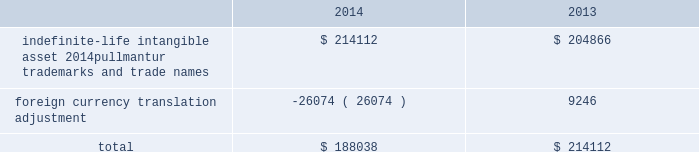Royal caribbean cruises ltd .
79 notes to the consolidated financial statements in 2012 , we determined the implied fair value of good- will for the pullmantur reporting unit was $ 145.5 mil- lion and recognized an impairment charge of $ 319.2 million based on a probability-weighted discounted cash flow model further discussed below .
This impair- ment charge was recognized in earnings during the fourth quarter of 2012 and is reported within impair- ment of pullmantur related assets within our consoli- dated statements of comprehensive income ( loss ) .
During the fourth quarter of 2014 , we performed a qualitative assessment of whether it was more-likely- than-not that our royal caribbean international reporting unit 2019s fair value was less than its carrying amount before applying the two-step goodwill impair- ment test .
The qualitative analysis included assessing the impact of certain factors such as general economic conditions , limitations on accessing capital , changes in forecasted operating results , changes in fuel prices and fluctuations in foreign exchange rates .
Based on our qualitative assessment , we concluded that it was more-likely-than-not that the estimated fair value of the royal caribbean international reporting unit exceeded its carrying value and thus , we did not pro- ceed to the two-step goodwill impairment test .
No indicators of impairment exist primarily because the reporting unit 2019s fair value has consistently exceeded its carrying value by a significant margin , its financial performance has been solid in the face of mixed economic environments and forecasts of operating results generated by the reporting unit appear suffi- cient to support its carrying value .
We also performed our annual impairment review of goodwill for pullmantur 2019s reporting unit during the fourth quarter of 2014 .
We did not perform a quali- tative assessment but instead proceeded directly to the two-step goodwill impairment test .
We estimated the fair value of the pullmantur reporting unit using a probability-weighted discounted cash flow model .
The principal assumptions used in the discounted cash flow model are projected operating results , weighted- average cost of capital , and terminal value .
Signifi- cantly impacting these assumptions are the transfer of vessels from our other cruise brands to pullmantur .
The discounted cash flow model used our 2015 pro- jected operating results as a base .
To that base , we added future years 2019 cash flows assuming multiple rev- enue and expense scenarios that reflect the impact of different global economic environments beyond 2015 on pullmantur 2019s reporting unit .
We assigned a probability to each revenue and expense scenario .
We discounted the projected cash flows using rates specific to pullmantur 2019s reporting unit based on its weighted-average cost of capital .
Based on the probability-weighted discounted cash flows , we deter- mined the fair value of the pullmantur reporting unit exceeded its carrying value by approximately 52% ( 52 % ) resulting in no impairment to pullmantur 2019s goodwill .
Pullmantur is a brand targeted primarily at the spanish , portuguese and latin american markets , with an increasing focus on latin america .
The persistent economic instability in these markets has created sig- nificant uncertainties in forecasting operating results and future cash flows used in our impairment analyses .
We continue to monitor economic events in these markets for their potential impact on pullmantur 2019s business and valuation .
Further , the estimation of fair value utilizing discounted expected future cash flows includes numerous uncertainties which require our significant judgment when making assumptions of expected revenues , operating costs , marketing , sell- ing and administrative expenses , interest rates , ship additions and retirements as well as assumptions regarding the cruise vacation industry 2019s competitive environment and general economic and business conditions , among other factors .
If there are changes to the projected future cash flows used in the impairment analyses , especially in net yields or if certain transfers of vessels from our other cruise brands to the pullmantur fleet do not take place , it is possible that an impairment charge of pullmantur 2019s reporting unit 2019s goodwill may be required .
Of these factors , the planned transfers of vessels to the pullmantur fleet is most significant to the projected future cash flows .
If the transfers do not occur , we will likely fail step one of the impairment test .
Note 4 .
Intangible assets intangible assets are reported in other assets in our consolidated balance sheets and consist of the follow- ing ( in thousands ) : .
During the fourth quarter of 2014 , 2013 and 2012 , we performed the annual impairment review of pullmantur 2019s trademarks and trade names using a discounted cash flow model and the relief-from-royalty method to compare the fair value of these indefinite-lived intan- gible assets to its carrying value .
The royalty rate used is based on comparable royalty agreements in the tourism and hospitality industry .
We used a dis- count rate comparable to the rate used in valuing the pullmantur reporting unit in our goodwill impairment test .
Based on the results of our testing , we did not .
For 2013 and 2014 , what is the mathematical range for foreign currency translation adjustments? 
Computations: (9246 - -26074)
Answer: 35320.0. 